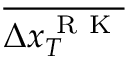<formula> <loc_0><loc_0><loc_500><loc_500>\overline { { \Delta x _ { T } ^ { R K } } }</formula> 